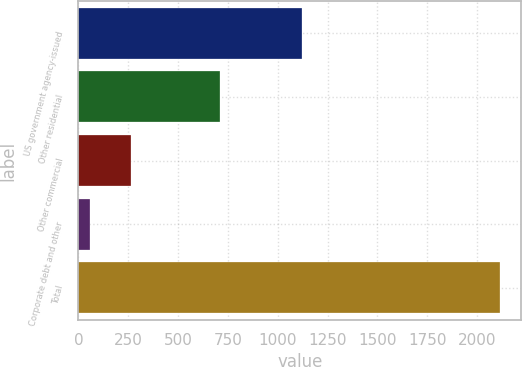Convert chart. <chart><loc_0><loc_0><loc_500><loc_500><bar_chart><fcel>US government agency-issued<fcel>Other residential<fcel>Other commercial<fcel>Corporate debt and other<fcel>Total<nl><fcel>1120<fcel>711<fcel>261.9<fcel>56<fcel>2115<nl></chart> 